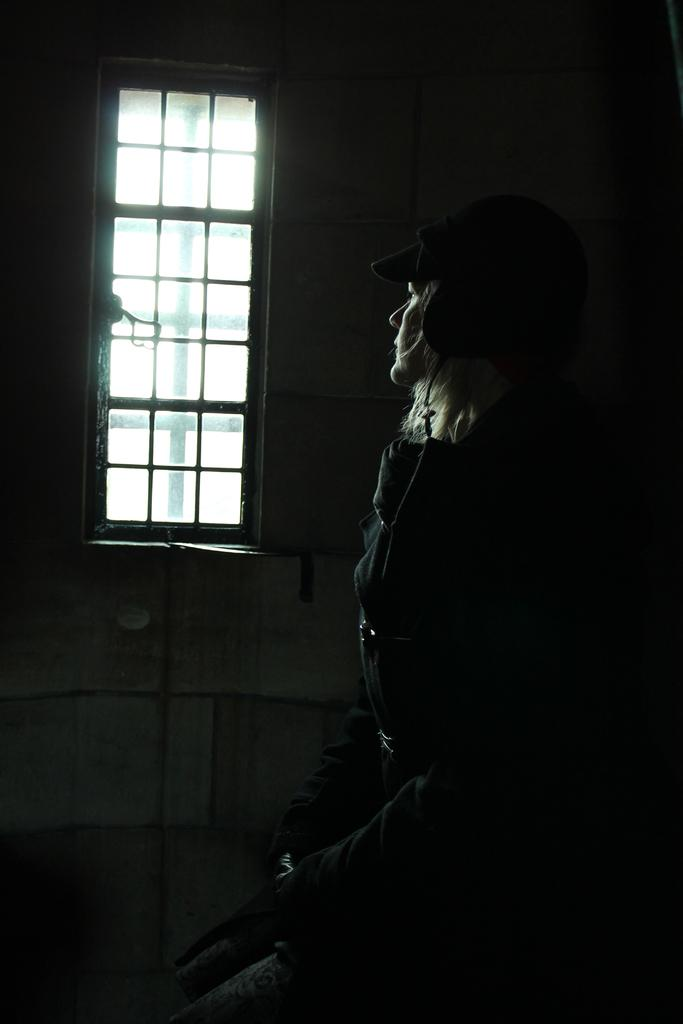Who is present in the image? There is a woman in the image. What can be seen behind the woman? There is a wall visible in the image. Is there any opening in the wall visible in the image? Yes, there is a window visible in the image. What type of volleyball game is being played in the image? There is no volleyball game present in the image. 